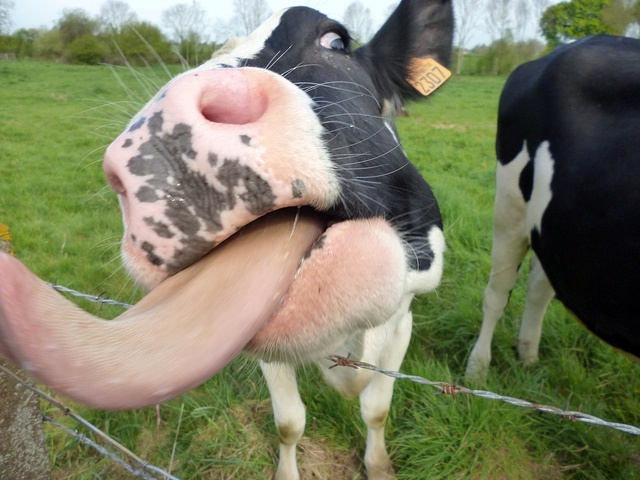Describe the objects in this image and their specific colors. I can see cow in lightblue, tan, lightgray, gray, and darkgray tones and cow in lightblue, black, gray, and darkgray tones in this image. 